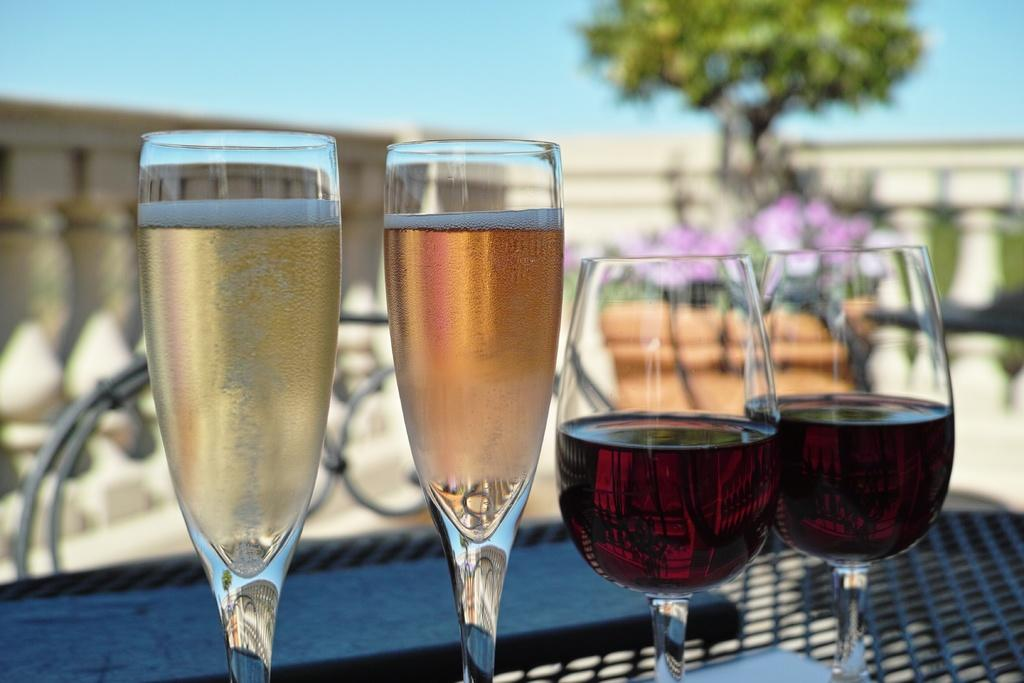How many glasses can be seen in the image? There are four glasses in the image. What can be seen in the background of the image? There is a tree, the sky, and a wall visible in the background of the image. What type of knowledge can be gained from the orange in the image? There is no orange present in the image, so no knowledge can be gained from it. 